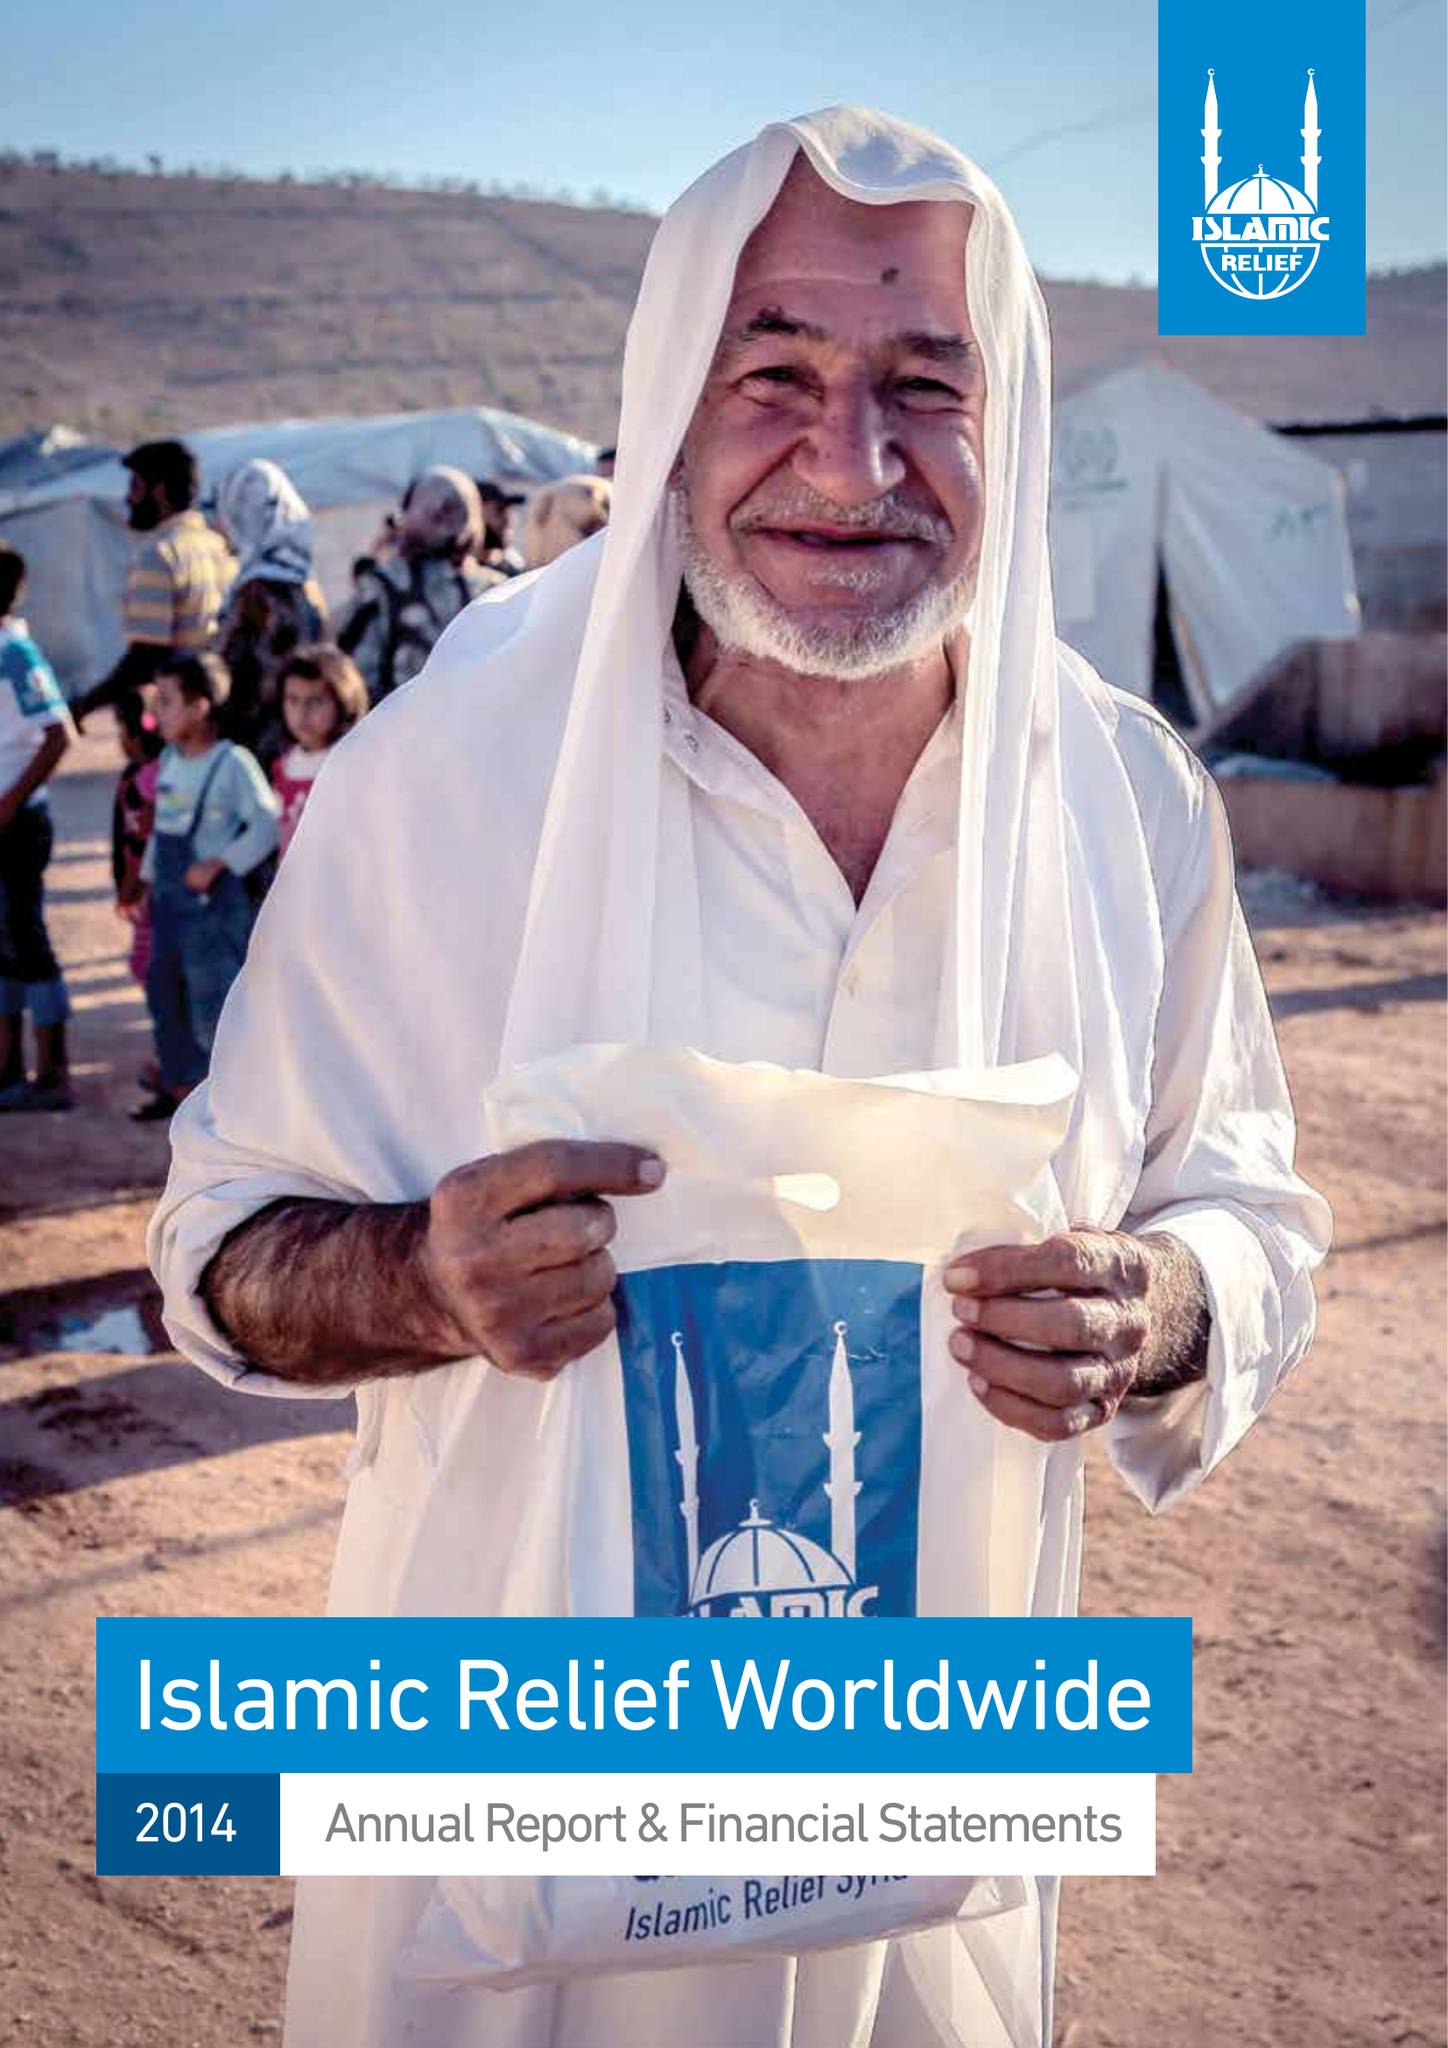What is the value for the address__street_line?
Answer the question using a single word or phrase. 19 REA STREET SOUTH 